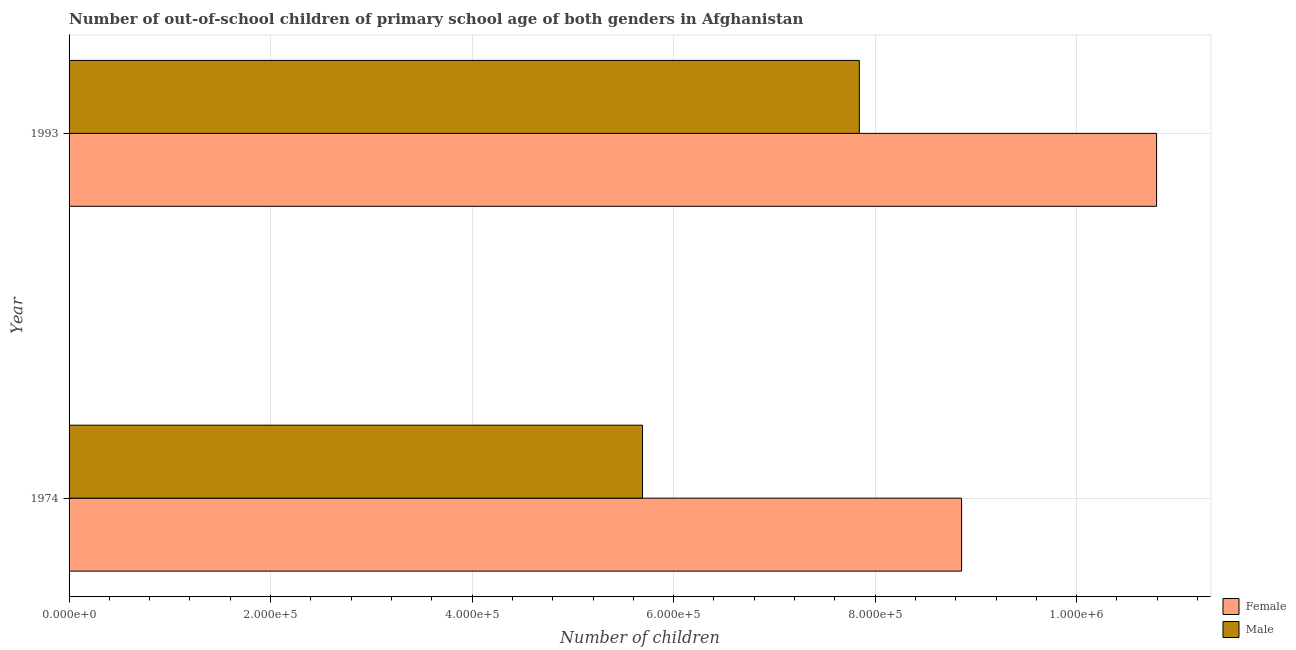How many different coloured bars are there?
Make the answer very short. 2. How many groups of bars are there?
Offer a very short reply. 2. Are the number of bars on each tick of the Y-axis equal?
Offer a terse response. Yes. How many bars are there on the 2nd tick from the top?
Your response must be concise. 2. What is the label of the 2nd group of bars from the top?
Provide a succinct answer. 1974. What is the number of male out-of-school students in 1993?
Offer a very short reply. 7.84e+05. Across all years, what is the maximum number of male out-of-school students?
Your response must be concise. 7.84e+05. Across all years, what is the minimum number of male out-of-school students?
Keep it short and to the point. 5.69e+05. In which year was the number of male out-of-school students maximum?
Ensure brevity in your answer.  1993. In which year was the number of female out-of-school students minimum?
Your answer should be very brief. 1974. What is the total number of male out-of-school students in the graph?
Provide a succinct answer. 1.35e+06. What is the difference between the number of female out-of-school students in 1974 and that in 1993?
Make the answer very short. -1.94e+05. What is the difference between the number of female out-of-school students in 1974 and the number of male out-of-school students in 1993?
Offer a terse response. 1.01e+05. What is the average number of male out-of-school students per year?
Provide a succinct answer. 6.77e+05. In the year 1993, what is the difference between the number of male out-of-school students and number of female out-of-school students?
Offer a terse response. -2.95e+05. What is the ratio of the number of male out-of-school students in 1974 to that in 1993?
Provide a short and direct response. 0.73. Is the number of male out-of-school students in 1974 less than that in 1993?
Keep it short and to the point. Yes. What does the 2nd bar from the bottom in 1974 represents?
Your answer should be compact. Male. Are all the bars in the graph horizontal?
Provide a short and direct response. Yes. How many years are there in the graph?
Your answer should be compact. 2. What is the difference between two consecutive major ticks on the X-axis?
Offer a very short reply. 2.00e+05. Does the graph contain any zero values?
Your response must be concise. No. How are the legend labels stacked?
Provide a succinct answer. Vertical. What is the title of the graph?
Offer a very short reply. Number of out-of-school children of primary school age of both genders in Afghanistan. Does "ODA received" appear as one of the legend labels in the graph?
Ensure brevity in your answer.  No. What is the label or title of the X-axis?
Your answer should be compact. Number of children. What is the label or title of the Y-axis?
Give a very brief answer. Year. What is the Number of children in Female in 1974?
Your answer should be very brief. 8.86e+05. What is the Number of children in Male in 1974?
Ensure brevity in your answer.  5.69e+05. What is the Number of children of Female in 1993?
Your answer should be compact. 1.08e+06. What is the Number of children of Male in 1993?
Offer a terse response. 7.84e+05. Across all years, what is the maximum Number of children of Female?
Your answer should be very brief. 1.08e+06. Across all years, what is the maximum Number of children in Male?
Your answer should be very brief. 7.84e+05. Across all years, what is the minimum Number of children of Female?
Your answer should be compact. 8.86e+05. Across all years, what is the minimum Number of children in Male?
Make the answer very short. 5.69e+05. What is the total Number of children in Female in the graph?
Provide a short and direct response. 1.97e+06. What is the total Number of children of Male in the graph?
Your response must be concise. 1.35e+06. What is the difference between the Number of children of Female in 1974 and that in 1993?
Your answer should be very brief. -1.94e+05. What is the difference between the Number of children in Male in 1974 and that in 1993?
Your response must be concise. -2.15e+05. What is the difference between the Number of children in Female in 1974 and the Number of children in Male in 1993?
Make the answer very short. 1.01e+05. What is the average Number of children in Female per year?
Keep it short and to the point. 9.83e+05. What is the average Number of children in Male per year?
Your answer should be compact. 6.77e+05. In the year 1974, what is the difference between the Number of children of Female and Number of children of Male?
Provide a succinct answer. 3.17e+05. In the year 1993, what is the difference between the Number of children in Female and Number of children in Male?
Make the answer very short. 2.95e+05. What is the ratio of the Number of children of Female in 1974 to that in 1993?
Your response must be concise. 0.82. What is the ratio of the Number of children of Male in 1974 to that in 1993?
Provide a succinct answer. 0.73. What is the difference between the highest and the second highest Number of children in Female?
Offer a terse response. 1.94e+05. What is the difference between the highest and the second highest Number of children in Male?
Give a very brief answer. 2.15e+05. What is the difference between the highest and the lowest Number of children in Female?
Make the answer very short. 1.94e+05. What is the difference between the highest and the lowest Number of children of Male?
Your response must be concise. 2.15e+05. 